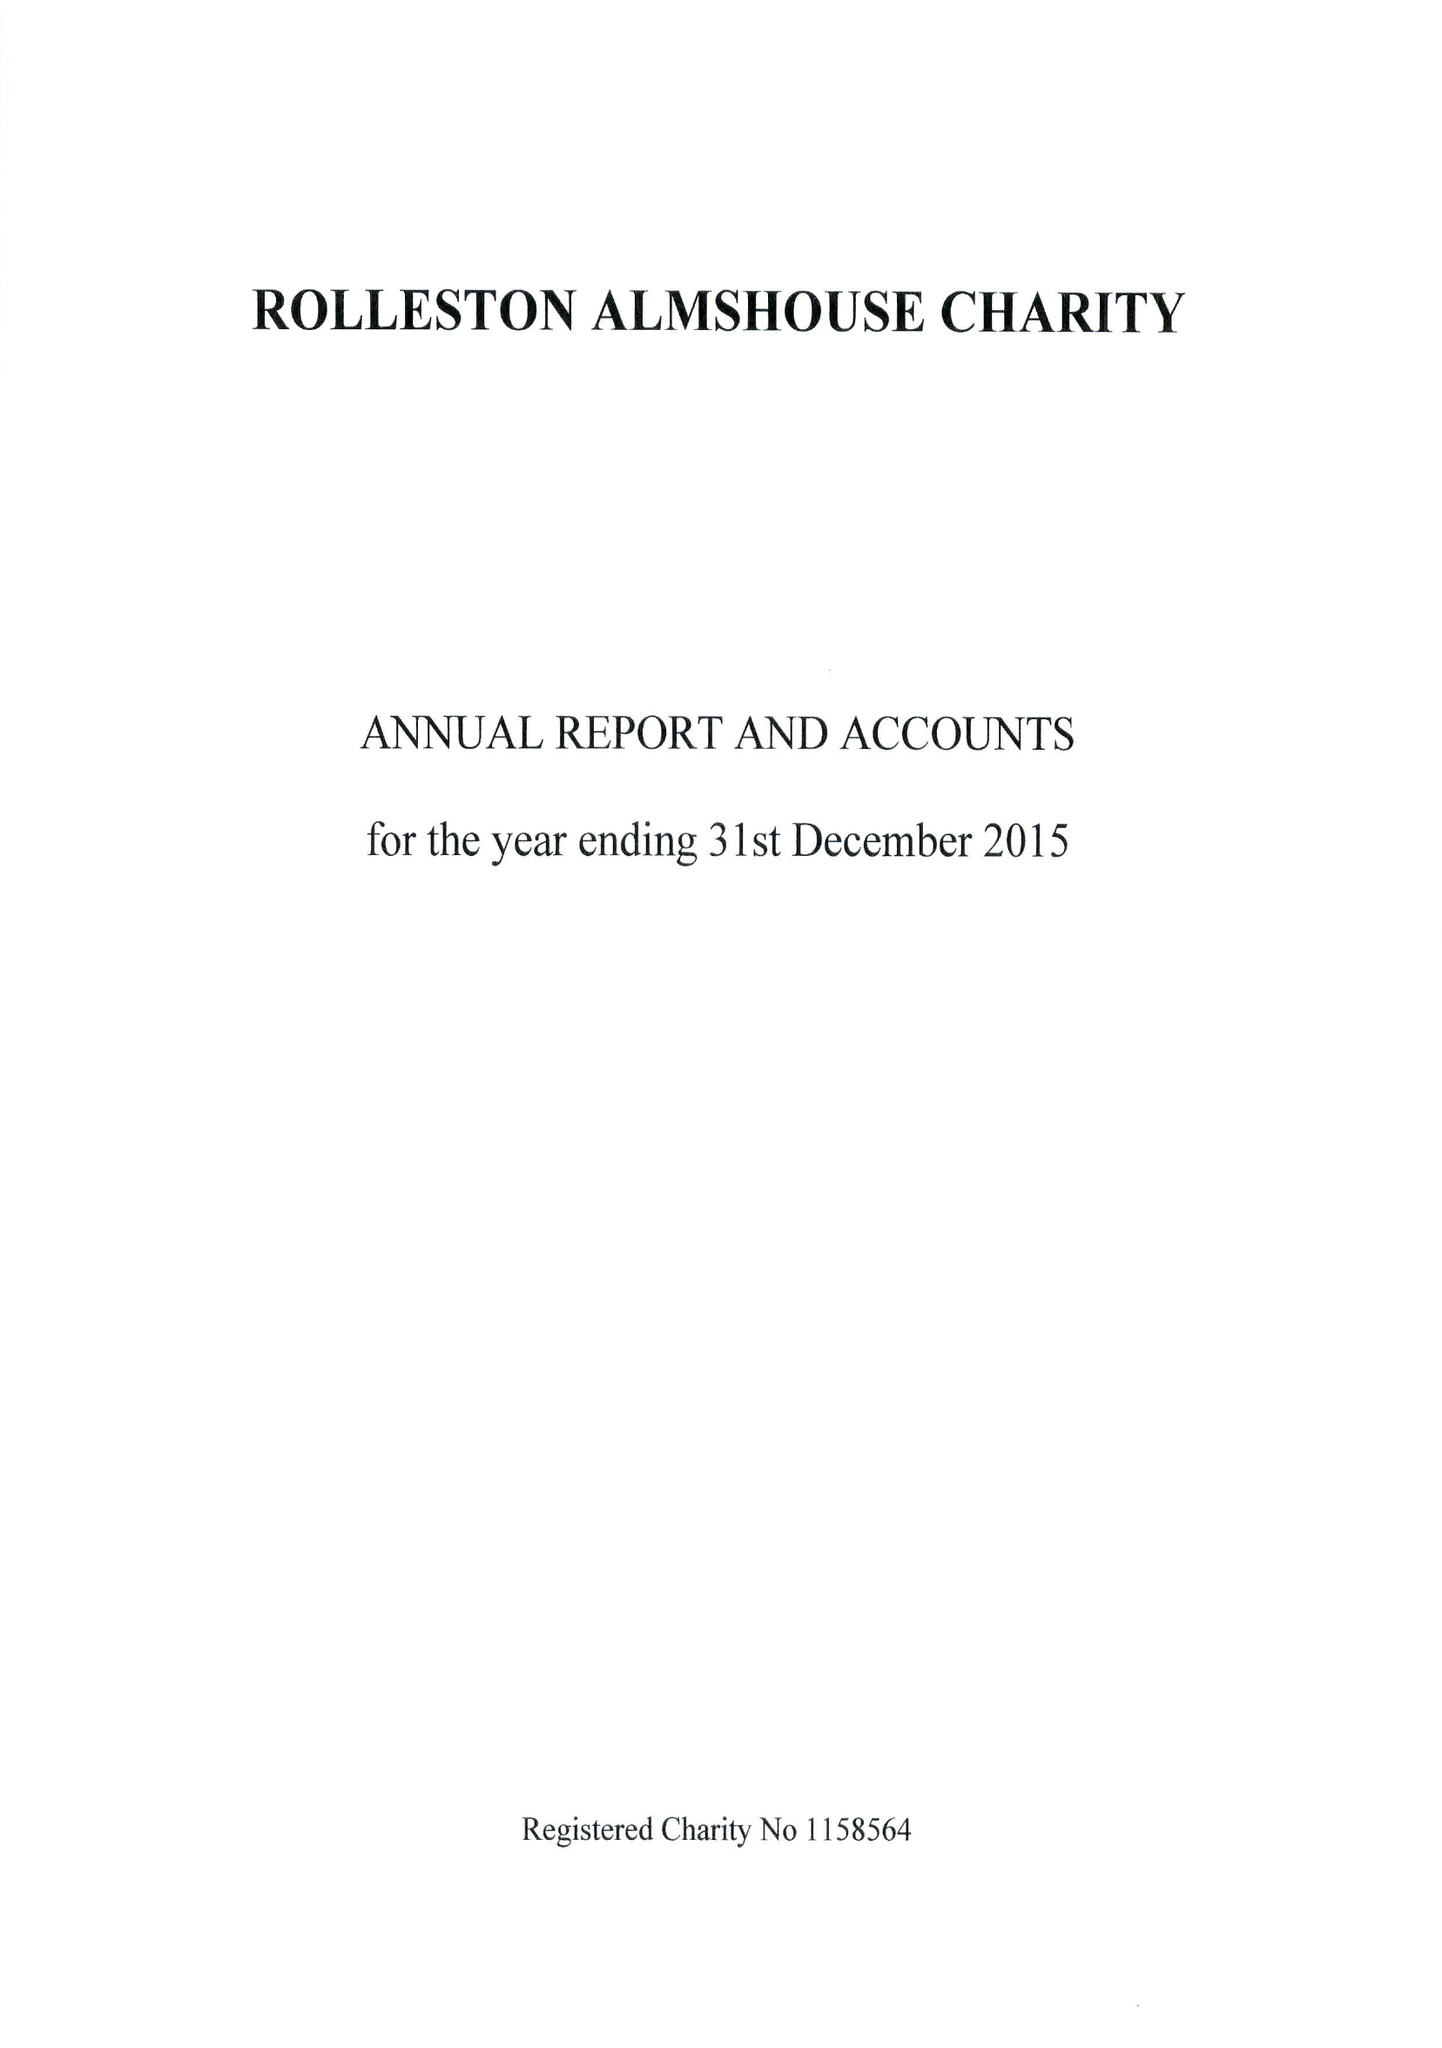What is the value for the address__postcode?
Answer the question using a single word or phrase. DE14 1JY 